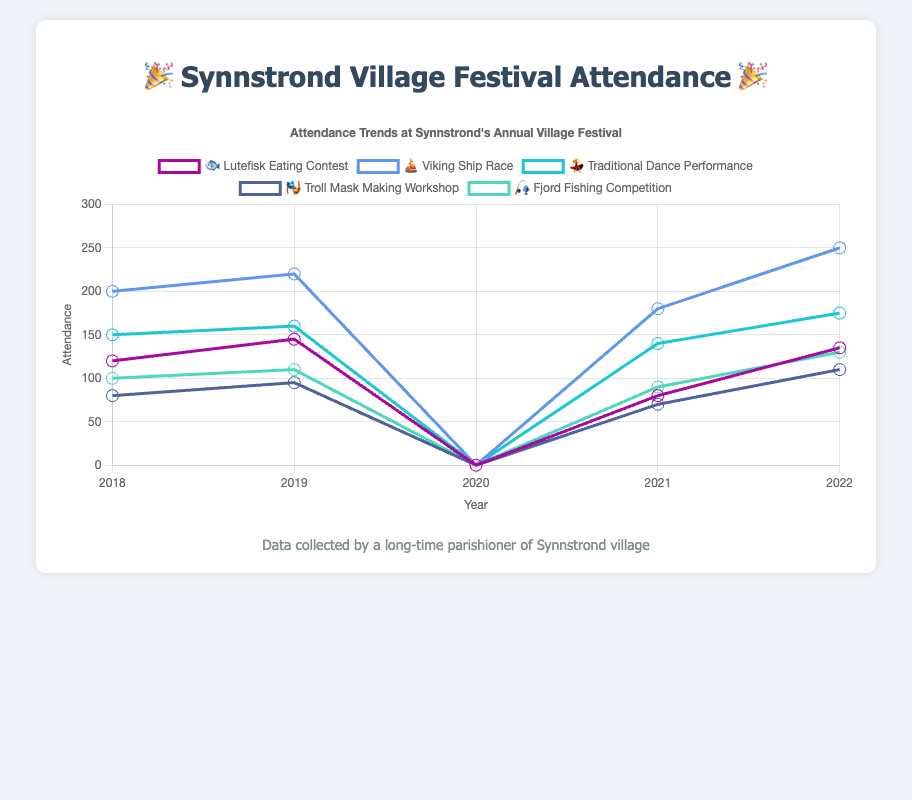What's the attendance trend for the Lutefisk Eating Contest 🐟 over the years? Look at the data points for the Lutefisk Eating Contest, represented by the '🐟' emoji on the chart. Track the y-values across the years 2018 to 2022. The attendance starts at 120 in 2018, rising to 145 in 2019, dropping to 0 in 2020, then increasing to 80 in 2021 and finally 135 in 2022.
Answer: Mixed trend with a peak in 2019, a drop to zero in 2020, and a recovery after that Which activity had the highest attendance in 2022? Check the y-value for all activities in 2022. The Viking Ship Race ⛵ has the highest attendance at 250, compared to other activities which have lower attendance.
Answer: Viking Ship Race ⛵ What was the effect of the year 2020 on all activities? Notice that for all activities in 2020, the attendance is 0. This indicates that there was no attendance for any activity in 2020, likely due to an event cancellation.
Answer: No attendance for all activities Compare the attendance of the Viking Ship Race ⛵ and the Traditional Dance Performance 💃 in 2019. Which was higher and by how much? Look at the data points for 2019. The Viking Ship Race ⛵ had an attendance of 220, and the Traditional Dance Performance 💃 had 160. The Viking Ship Race ⛵ attendance is higher by 220 - 160 = 60.
Answer: Viking Ship Race ⛵ by 60 attendees What is the average attendance of the Troll Mask Making Workshop 🎭 from 2018 to 2022, excluding 2020? Sum the attendance for the Troll Mask Making Workshop 🎭 between 2018 and 2022, excluding 2020: (80 + 95 + 70 + 110). Then divide by the number of years (4). The total sum is 355. The average is 355 / 4 = 88.75.
Answer: 88.75 Which activity had the most steady attendance trend excluding the year 2020? Examine the attendance values for each activity from 2018 to 2022, excluding 2020. The Traditional Dance Performance 💃 shows relatively steady attendance with values of 150, 160, 140, and 175. Others show more fluctuation.
Answer: Traditional Dance Performance 💃 Between 2018 and 2022, which activity had the highest drop in attendance in any single year? Identify the largest drop in attendance for each activity between any two years from 2018 to 2022. The Lutefisk Eating Contest 🐟 experienced the highest drop from 145 in 2019 to 0 in 2020, a drop of 145.
Answer: Lutefisk Eating Contest 🐟 How did the Fjord Fishing Competition 🎣 fare in attendance from 2021 to 2022? Observe the attendance for the Fjord Fishing Competition 🎣 in 2021 and 2022. The attendance increased from 90 in 2021 to 130 in 2022, indicating a rise of 40.
Answer: Increased by 40 attendees 